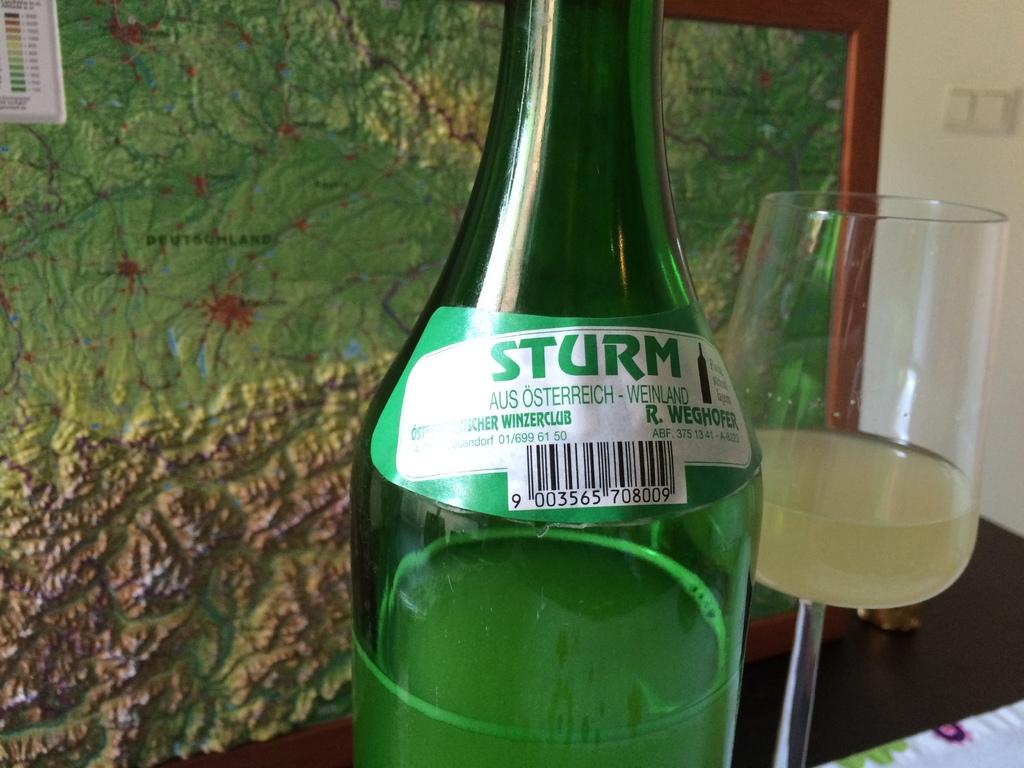What brand is the beverage in the image?
Provide a short and direct response. Sturm. What is the first number on the upc label?
Offer a very short reply. 9. 